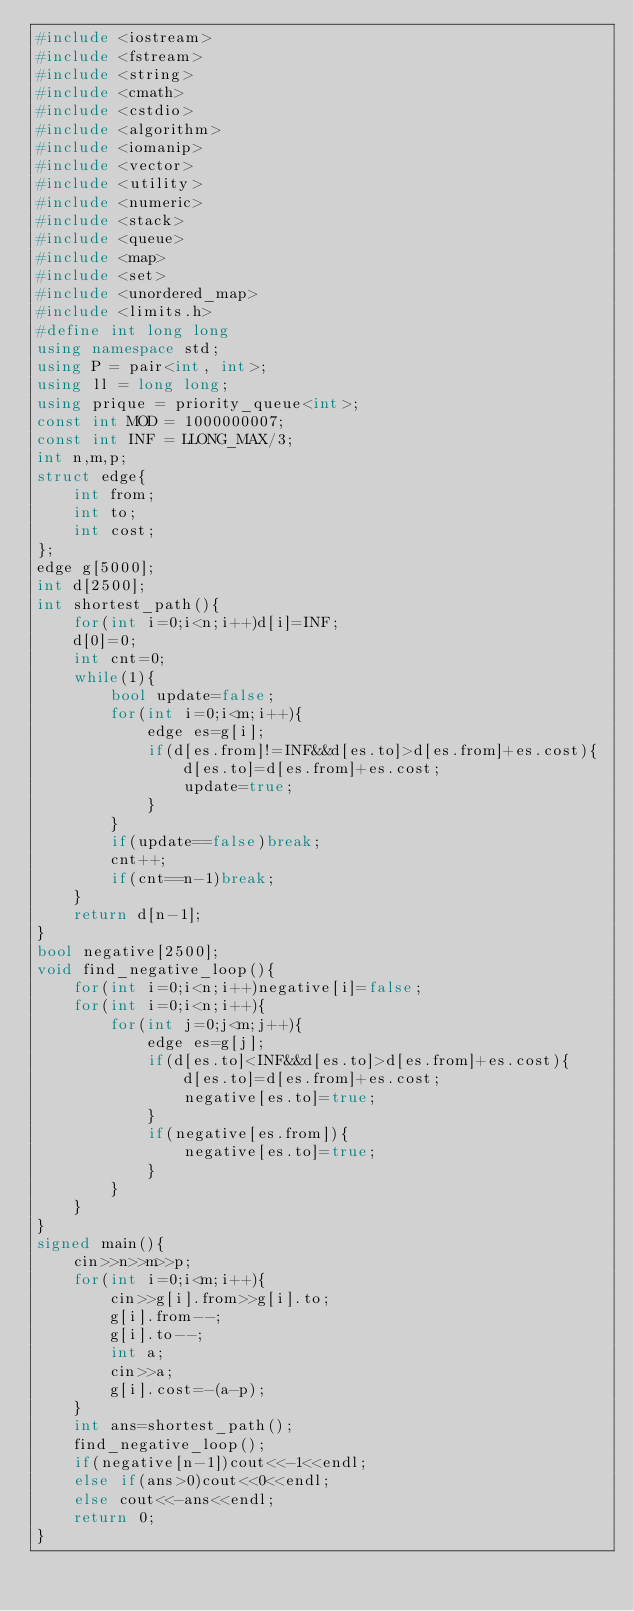Convert code to text. <code><loc_0><loc_0><loc_500><loc_500><_C++_>#include <iostream>
#include <fstream>
#include <string>
#include <cmath>
#include <cstdio>
#include <algorithm>
#include <iomanip>
#include <vector>
#include <utility>
#include <numeric>
#include <stack>
#include <queue>
#include <map>
#include <set>
#include <unordered_map>
#include <limits.h>
#define int long long
using namespace std;
using P = pair<int, int>;
using ll = long long;
using prique = priority_queue<int>;
const int MOD = 1000000007;
const int INF = LLONG_MAX/3;
int n,m,p;
struct edge{
    int from;
    int to;
    int cost;
};
edge g[5000];
int d[2500];
int shortest_path(){
    for(int i=0;i<n;i++)d[i]=INF;
    d[0]=0;
    int cnt=0;
    while(1){
        bool update=false;
        for(int i=0;i<m;i++){
            edge es=g[i];
            if(d[es.from]!=INF&&d[es.to]>d[es.from]+es.cost){
                d[es.to]=d[es.from]+es.cost;
                update=true;
            }
        }
        if(update==false)break;
        cnt++;
        if(cnt==n-1)break;
    }
    return d[n-1];
}
bool negative[2500];
void find_negative_loop(){
    for(int i=0;i<n;i++)negative[i]=false;
    for(int i=0;i<n;i++){
        for(int j=0;j<m;j++){
            edge es=g[j];
            if(d[es.to]<INF&&d[es.to]>d[es.from]+es.cost){
                d[es.to]=d[es.from]+es.cost;
                negative[es.to]=true;
            }
            if(negative[es.from]){
                negative[es.to]=true;
            }
        }
    }
}
signed main(){
    cin>>n>>m>>p;
    for(int i=0;i<m;i++){
        cin>>g[i].from>>g[i].to;
        g[i].from--;
        g[i].to--;
        int a;
        cin>>a;
        g[i].cost=-(a-p);
    }
    int ans=shortest_path();
    find_negative_loop();
    if(negative[n-1])cout<<-1<<endl;
    else if(ans>0)cout<<0<<endl;
    else cout<<-ans<<endl;
    return 0;
}
</code> 